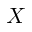<formula> <loc_0><loc_0><loc_500><loc_500>X</formula> 